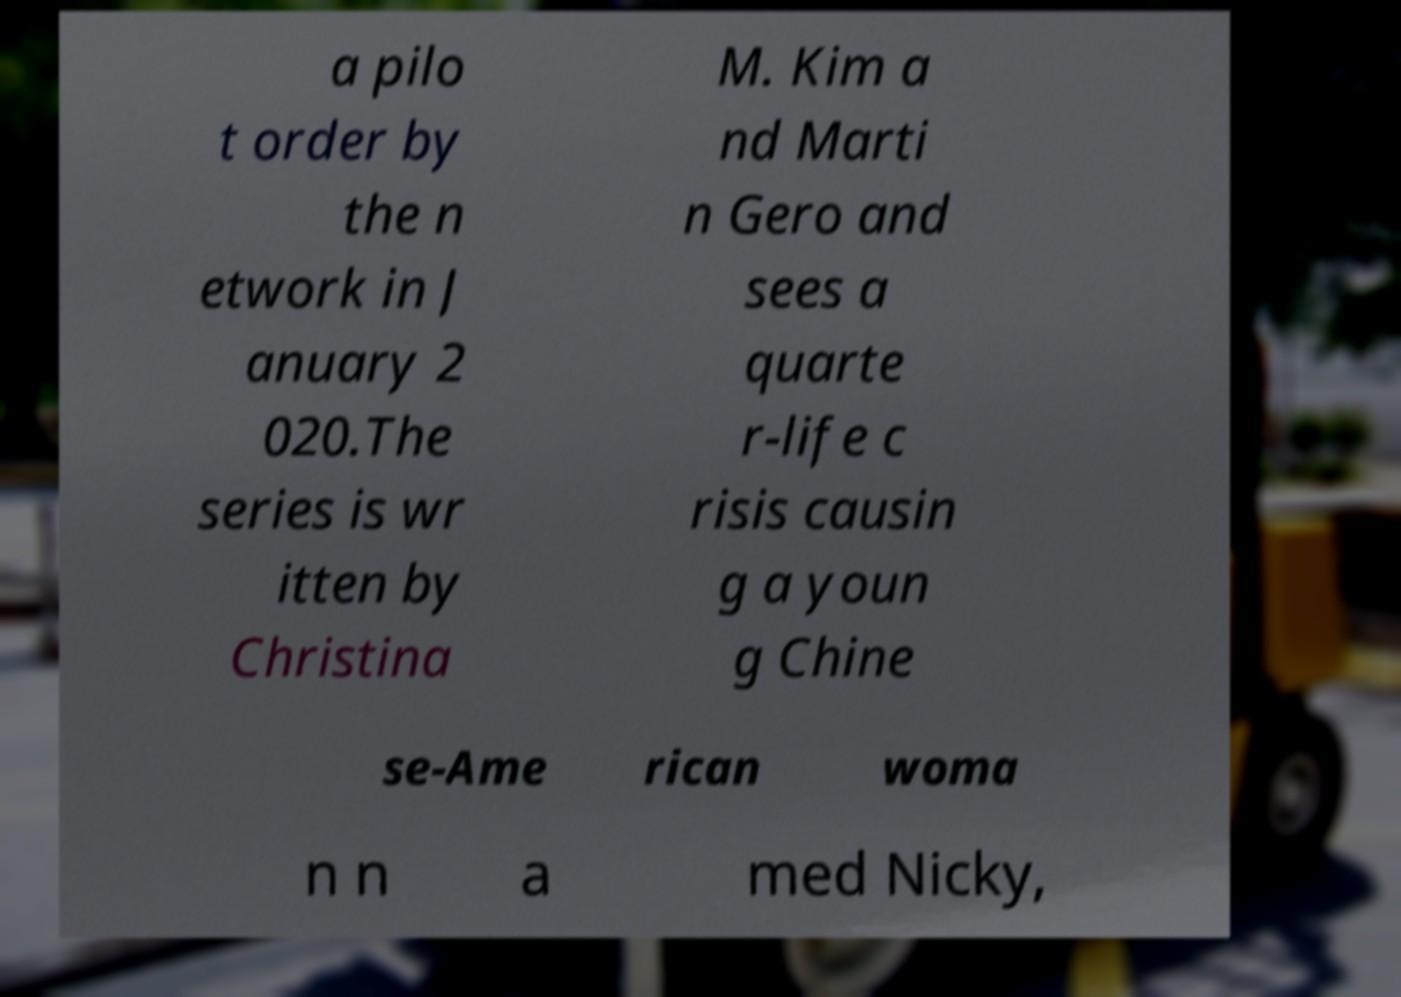Could you assist in decoding the text presented in this image and type it out clearly? a pilo t order by the n etwork in J anuary 2 020.The series is wr itten by Christina M. Kim a nd Marti n Gero and sees a quarte r-life c risis causin g a youn g Chine se-Ame rican woma n n a med Nicky, 